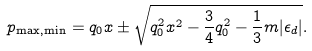Convert formula to latex. <formula><loc_0><loc_0><loc_500><loc_500>p _ { \max , \min } = q _ { 0 } x \pm \sqrt { q _ { 0 } ^ { 2 } x ^ { 2 } - { \frac { 3 } { 4 } } q _ { 0 } ^ { 2 } - { \frac { 1 } { 3 } } m | \epsilon _ { d } | } .</formula> 